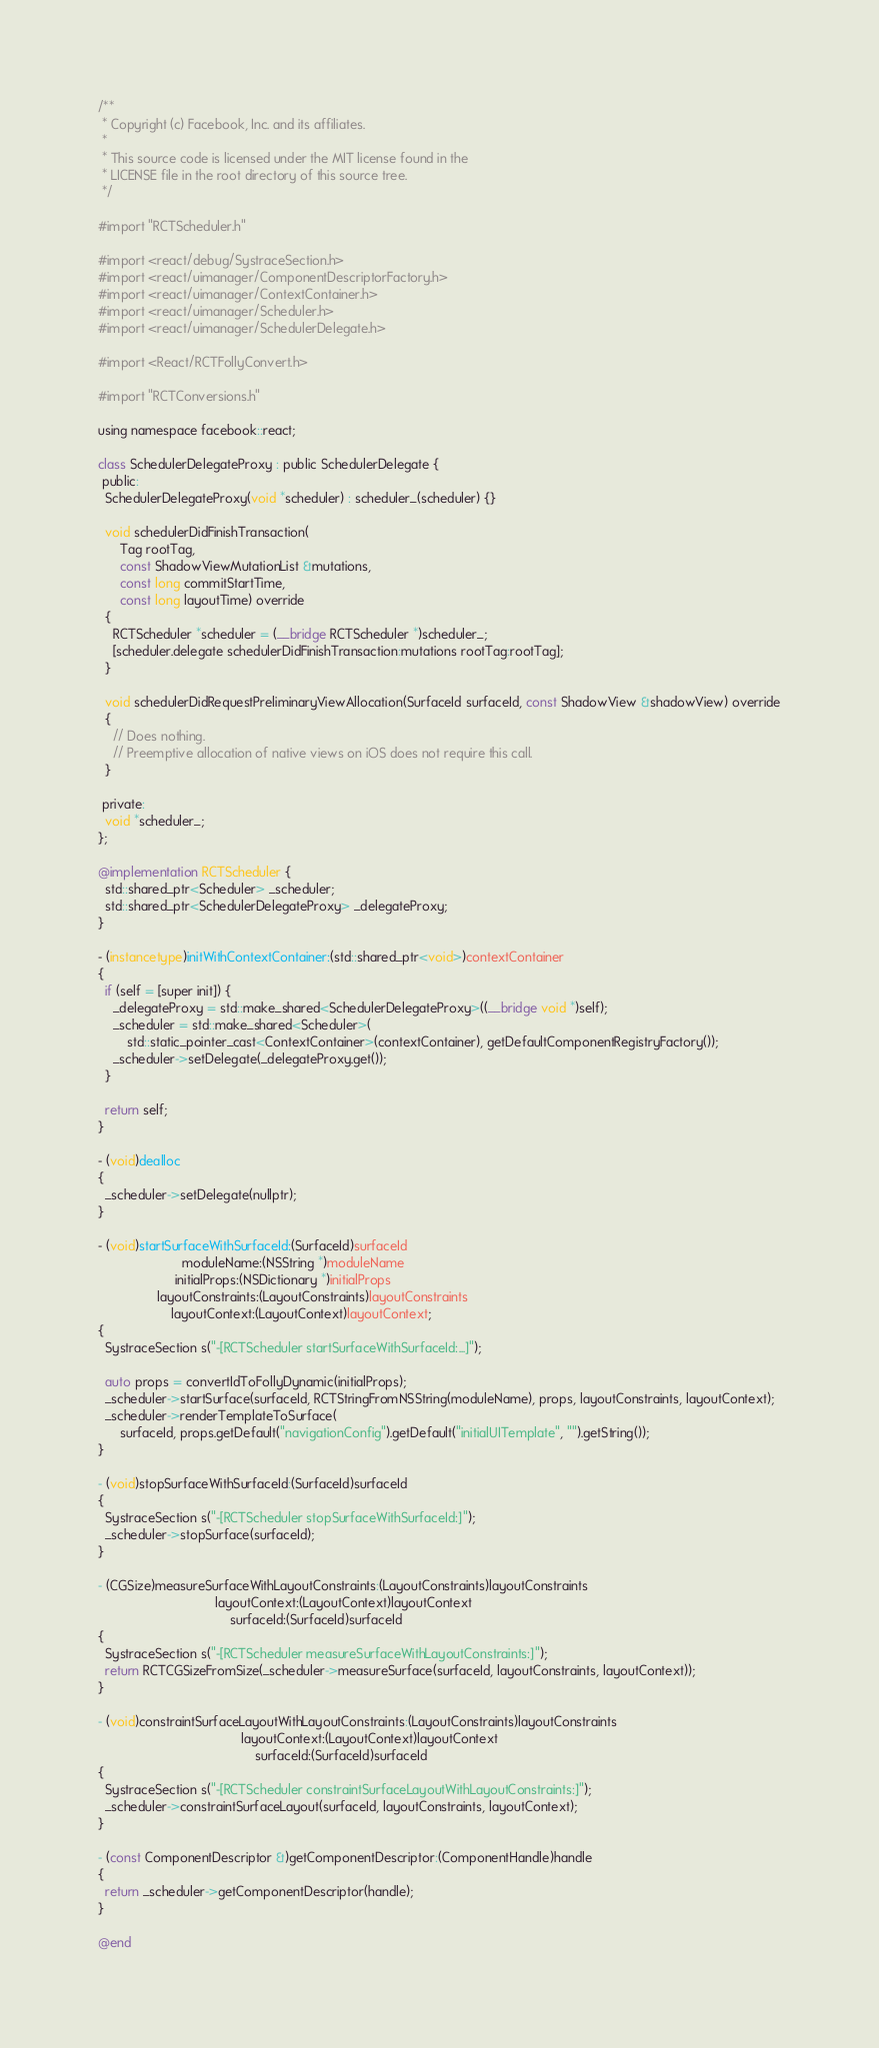<code> <loc_0><loc_0><loc_500><loc_500><_ObjectiveC_>/**
 * Copyright (c) Facebook, Inc. and its affiliates.
 *
 * This source code is licensed under the MIT license found in the
 * LICENSE file in the root directory of this source tree.
 */

#import "RCTScheduler.h"

#import <react/debug/SystraceSection.h>
#import <react/uimanager/ComponentDescriptorFactory.h>
#import <react/uimanager/ContextContainer.h>
#import <react/uimanager/Scheduler.h>
#import <react/uimanager/SchedulerDelegate.h>

#import <React/RCTFollyConvert.h>

#import "RCTConversions.h"

using namespace facebook::react;

class SchedulerDelegateProxy : public SchedulerDelegate {
 public:
  SchedulerDelegateProxy(void *scheduler) : scheduler_(scheduler) {}

  void schedulerDidFinishTransaction(
      Tag rootTag,
      const ShadowViewMutationList &mutations,
      const long commitStartTime,
      const long layoutTime) override
  {
    RCTScheduler *scheduler = (__bridge RCTScheduler *)scheduler_;
    [scheduler.delegate schedulerDidFinishTransaction:mutations rootTag:rootTag];
  }

  void schedulerDidRequestPreliminaryViewAllocation(SurfaceId surfaceId, const ShadowView &shadowView) override
  {
    // Does nothing.
    // Preemptive allocation of native views on iOS does not require this call.
  }

 private:
  void *scheduler_;
};

@implementation RCTScheduler {
  std::shared_ptr<Scheduler> _scheduler;
  std::shared_ptr<SchedulerDelegateProxy> _delegateProxy;
}

- (instancetype)initWithContextContainer:(std::shared_ptr<void>)contextContainer
{
  if (self = [super init]) {
    _delegateProxy = std::make_shared<SchedulerDelegateProxy>((__bridge void *)self);
    _scheduler = std::make_shared<Scheduler>(
        std::static_pointer_cast<ContextContainer>(contextContainer), getDefaultComponentRegistryFactory());
    _scheduler->setDelegate(_delegateProxy.get());
  }

  return self;
}

- (void)dealloc
{
  _scheduler->setDelegate(nullptr);
}

- (void)startSurfaceWithSurfaceId:(SurfaceId)surfaceId
                       moduleName:(NSString *)moduleName
                     initialProps:(NSDictionary *)initialProps
                layoutConstraints:(LayoutConstraints)layoutConstraints
                    layoutContext:(LayoutContext)layoutContext;
{
  SystraceSection s("-[RCTScheduler startSurfaceWithSurfaceId:...]");

  auto props = convertIdToFollyDynamic(initialProps);
  _scheduler->startSurface(surfaceId, RCTStringFromNSString(moduleName), props, layoutConstraints, layoutContext);
  _scheduler->renderTemplateToSurface(
      surfaceId, props.getDefault("navigationConfig").getDefault("initialUITemplate", "").getString());
}

- (void)stopSurfaceWithSurfaceId:(SurfaceId)surfaceId
{
  SystraceSection s("-[RCTScheduler stopSurfaceWithSurfaceId:]");
  _scheduler->stopSurface(surfaceId);
}

- (CGSize)measureSurfaceWithLayoutConstraints:(LayoutConstraints)layoutConstraints
                                layoutContext:(LayoutContext)layoutContext
                                    surfaceId:(SurfaceId)surfaceId
{
  SystraceSection s("-[RCTScheduler measureSurfaceWithLayoutConstraints:]");
  return RCTCGSizeFromSize(_scheduler->measureSurface(surfaceId, layoutConstraints, layoutContext));
}

- (void)constraintSurfaceLayoutWithLayoutConstraints:(LayoutConstraints)layoutConstraints
                                       layoutContext:(LayoutContext)layoutContext
                                           surfaceId:(SurfaceId)surfaceId
{
  SystraceSection s("-[RCTScheduler constraintSurfaceLayoutWithLayoutConstraints:]");
  _scheduler->constraintSurfaceLayout(surfaceId, layoutConstraints, layoutContext);
}

- (const ComponentDescriptor &)getComponentDescriptor:(ComponentHandle)handle
{
  return _scheduler->getComponentDescriptor(handle);
}

@end
</code> 